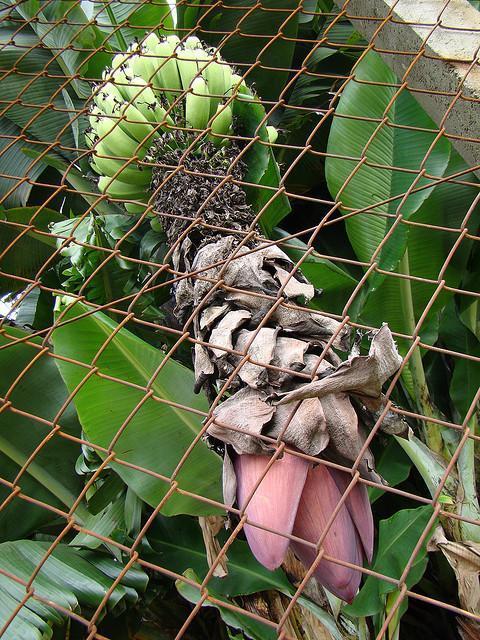How many rolls of white toilet paper are in the bathroom?
Give a very brief answer. 0. 